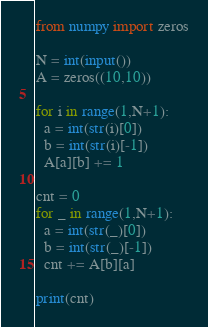Convert code to text. <code><loc_0><loc_0><loc_500><loc_500><_Python_>from numpy import zeros
 
N = int(input())
A = zeros((10,10))
 
for i in range(1,N+1):
  a = int(str(i)[0])
  b = int(str(i)[-1])
  A[a][b] += 1
 
cnt = 0
for _ in range(1,N+1):
  a = int(str(_)[0])
  b = int(str(_)[-1])
  cnt += A[b][a]
  
print(cnt)</code> 